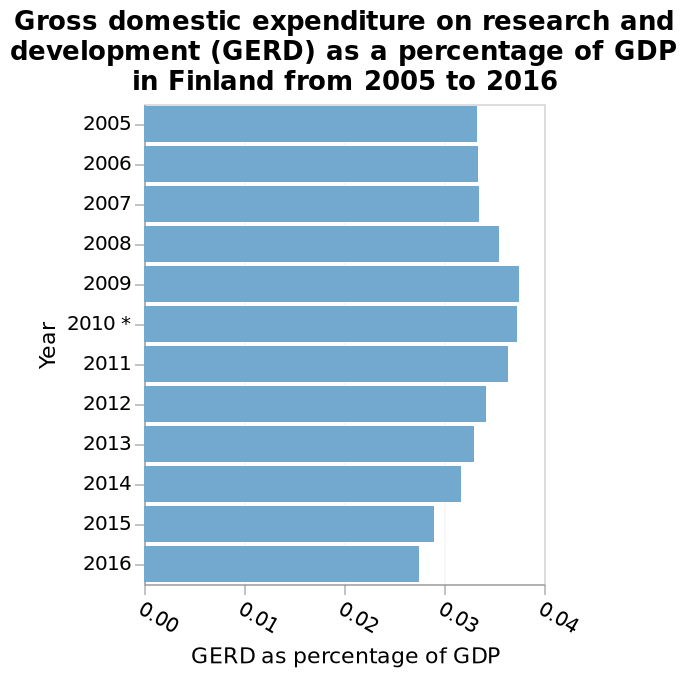<image>
Offer a thorough analysis of the image. The percentage of money spent on research relative to GDP increases from 2005 to its highest in 2009 it then steadily falls to its lowest point at 2016. What is the range of values shown on the x-axis? The x-axis shows values ranging from 0.00 to 0.04, representing GERD as a percentage of GDP. What year had the highest expenditure on research and development? 2009 What is the minimum value shown on the y-axis? The minimum value shown on the y-axis is 2005. 